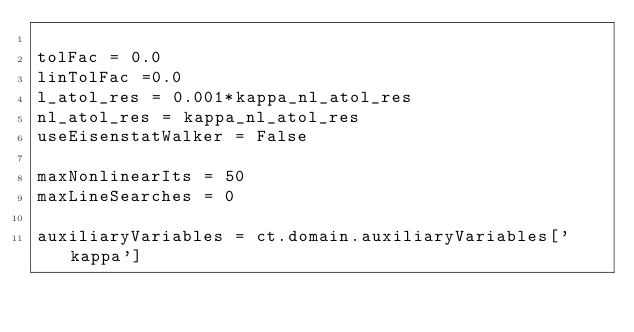Convert code to text. <code><loc_0><loc_0><loc_500><loc_500><_Python_>
tolFac = 0.0
linTolFac =0.0
l_atol_res = 0.001*kappa_nl_atol_res
nl_atol_res = kappa_nl_atol_res
useEisenstatWalker = False

maxNonlinearIts = 50
maxLineSearches = 0

auxiliaryVariables = ct.domain.auxiliaryVariables['kappa']

</code> 